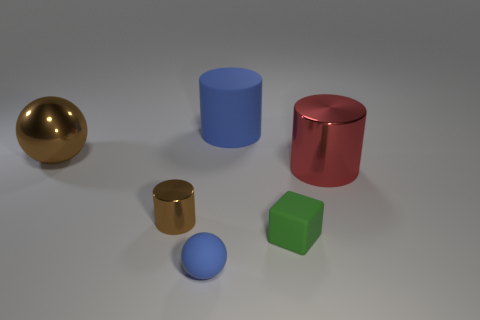Add 3 brown cylinders. How many objects exist? 9 Subtract all spheres. How many objects are left? 4 Add 4 small metallic cylinders. How many small metallic cylinders are left? 5 Add 6 cyan metal objects. How many cyan metal objects exist? 6 Subtract 1 brown cylinders. How many objects are left? 5 Subtract all large spheres. Subtract all red objects. How many objects are left? 4 